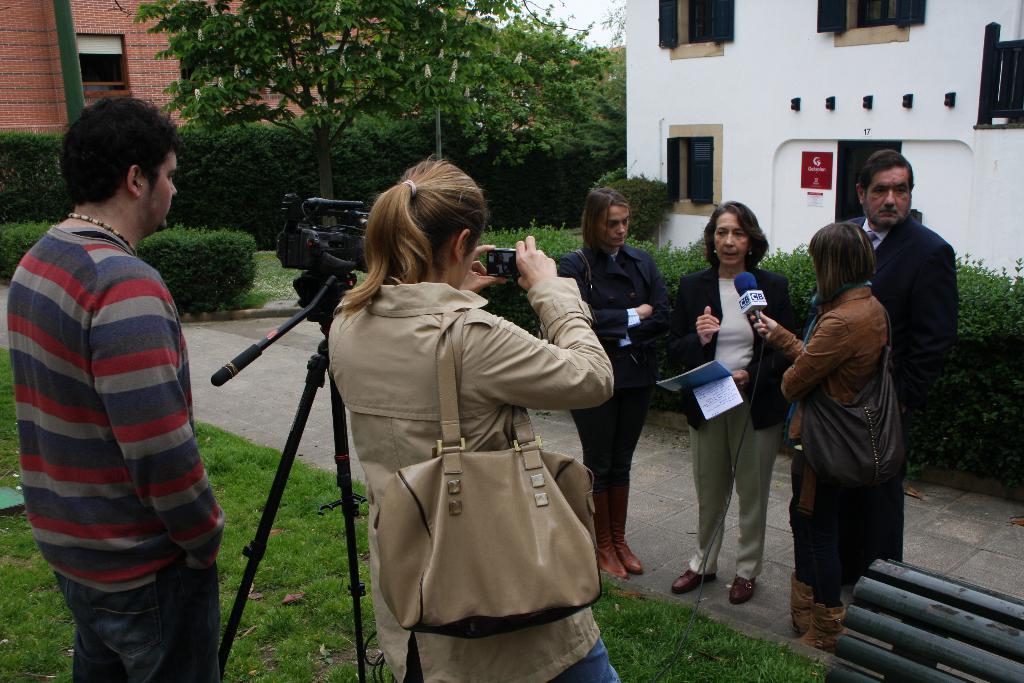Please provide a concise description of this image. Here in this picture, on the right side we can see a group of people standing on the ground and the woman in the middle is speaking something in the microphone present in front of her, which is held by another woman and she is holding some files in her hand and in front of her we can see a man and a woman standing on the ground, which is fully covered with grass and we can see a video camera present on a tripod and we can see the woman is carrying a hand bag and holding a mobile phone in her hand and we can also see other buildings with number of windows present and we can see plants, bushes and trees present. 